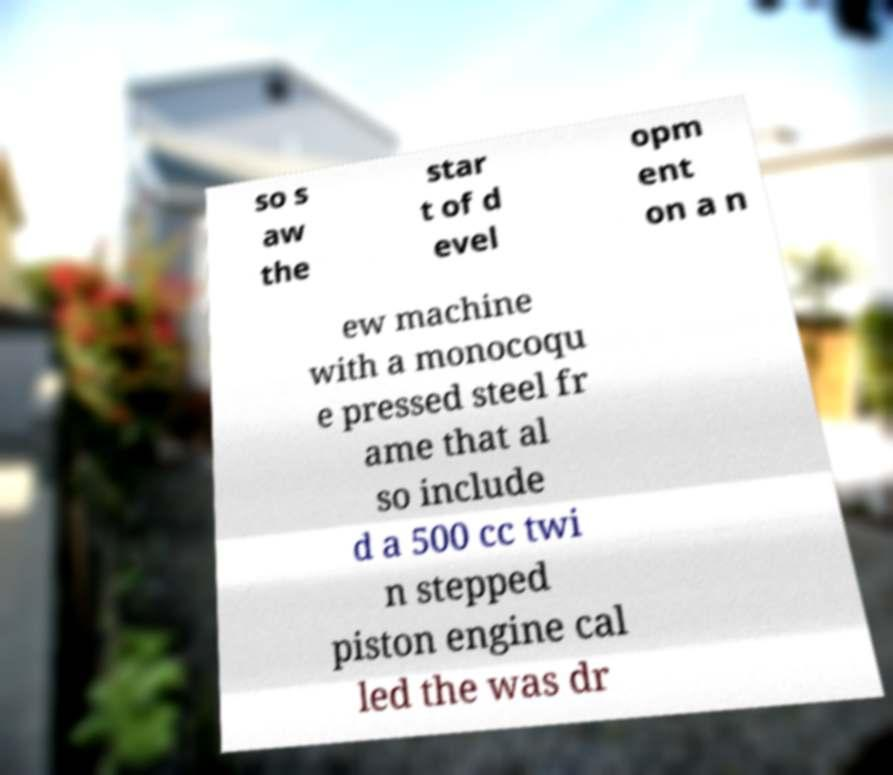Can you accurately transcribe the text from the provided image for me? so s aw the star t of d evel opm ent on a n ew machine with a monocoqu e pressed steel fr ame that al so include d a 500 cc twi n stepped piston engine cal led the was dr 